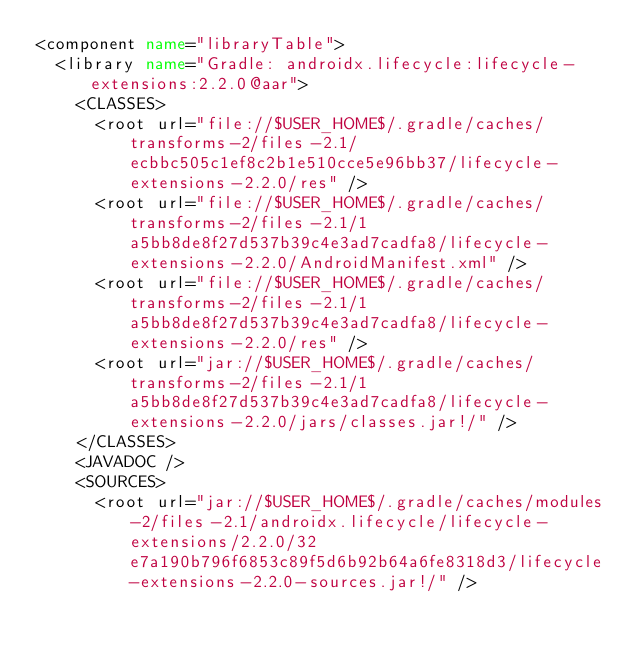Convert code to text. <code><loc_0><loc_0><loc_500><loc_500><_XML_><component name="libraryTable">
  <library name="Gradle: androidx.lifecycle:lifecycle-extensions:2.2.0@aar">
    <CLASSES>
      <root url="file://$USER_HOME$/.gradle/caches/transforms-2/files-2.1/ecbbc505c1ef8c2b1e510cce5e96bb37/lifecycle-extensions-2.2.0/res" />
      <root url="file://$USER_HOME$/.gradle/caches/transforms-2/files-2.1/1a5bb8de8f27d537b39c4e3ad7cadfa8/lifecycle-extensions-2.2.0/AndroidManifest.xml" />
      <root url="file://$USER_HOME$/.gradle/caches/transforms-2/files-2.1/1a5bb8de8f27d537b39c4e3ad7cadfa8/lifecycle-extensions-2.2.0/res" />
      <root url="jar://$USER_HOME$/.gradle/caches/transforms-2/files-2.1/1a5bb8de8f27d537b39c4e3ad7cadfa8/lifecycle-extensions-2.2.0/jars/classes.jar!/" />
    </CLASSES>
    <JAVADOC />
    <SOURCES>
      <root url="jar://$USER_HOME$/.gradle/caches/modules-2/files-2.1/androidx.lifecycle/lifecycle-extensions/2.2.0/32e7a190b796f6853c89f5d6b92b64a6fe8318d3/lifecycle-extensions-2.2.0-sources.jar!/" /></code> 